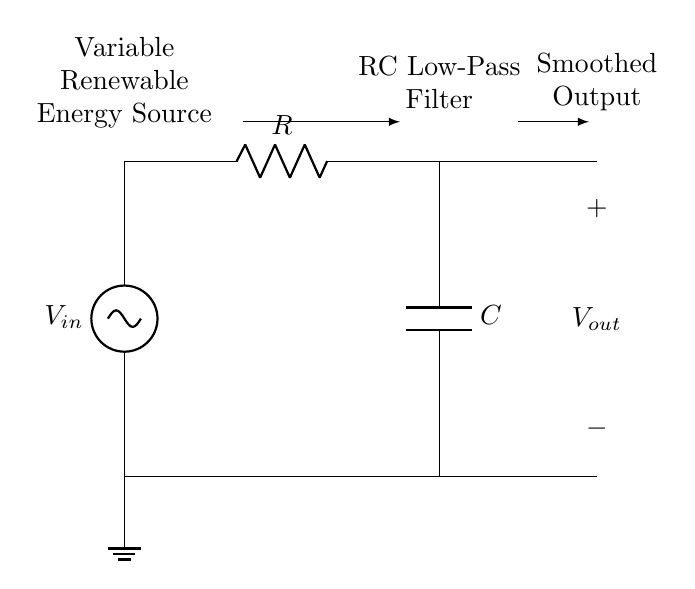What is the input voltage source labeled as? The input voltage source is labeled as V in. This is indicated at the top left of the circuit diagram.
Answer: V in What components are in the circuit? The circuit consists of a resistor and a capacitor, as indicated by the labels R and C in the diagram. There is also a voltage source represented as V in.
Answer: Resistor, Capacitor What does the RC filter do in this circuit? The RC filter smooths the output voltage, reducing fluctuations from the variable renewable energy source. It acts as a low-pass filter, allowing low-frequency signals through while attenuating high-frequency signals.
Answer: Smooths output What is the role of the resistor in the RC filter? The resistor limits the current flowing into the capacitor, thereby controlling the charging and discharging rates of the capacitor, which is essential for setting the time constant of the filter.
Answer: Current limiting What is the expected effect if the capacitance value is increased? Increasing the capacitance value will result in a longer time constant, allowing the capacitor to store more charge and output a more smoothed voltage over time. The output will stabilize to the average value faster and reduce ripple further.
Answer: More smoothing What is the output voltage labeled as? The output voltage is labeled as V out in the circuit diagram. This is positioned at the top of the circuit after the RC components.
Answer: V out What circuit type does this represent? This represents an RC low-pass filter circuit. This is specifically defined by its configuration of a resistor and a capacitor in series followed by a load.
Answer: RC low-pass filter 